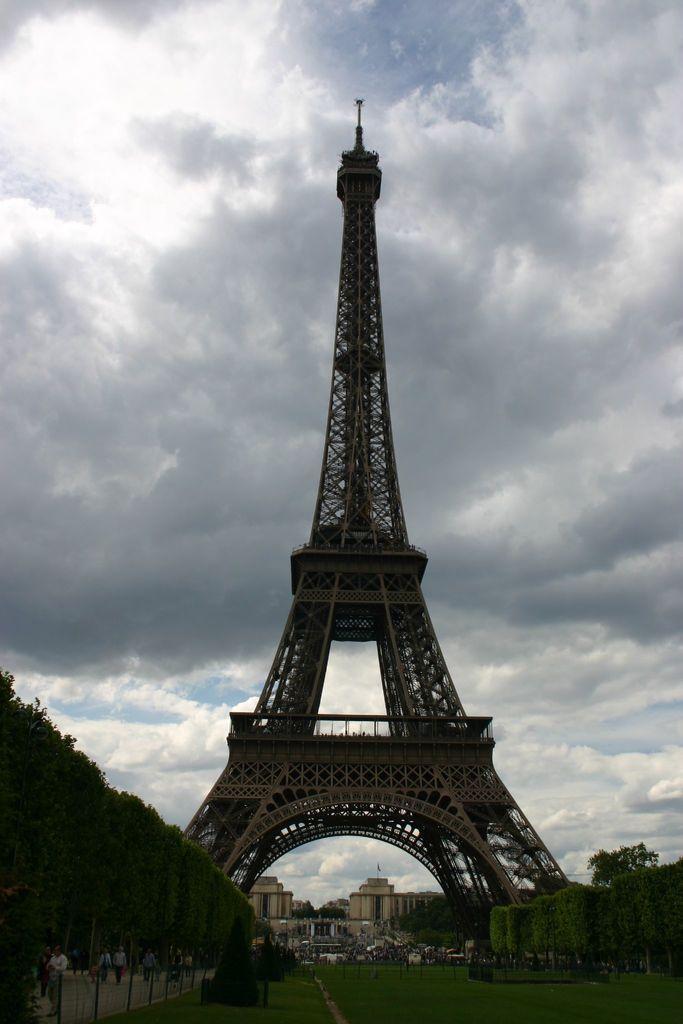Please provide a concise description of this image. In the center of the image there is a Eiffel tower. At the bottom of the image there is grass. To the both sides of the image there are plants. In the background of the image there is sky,clouds and buildings. 